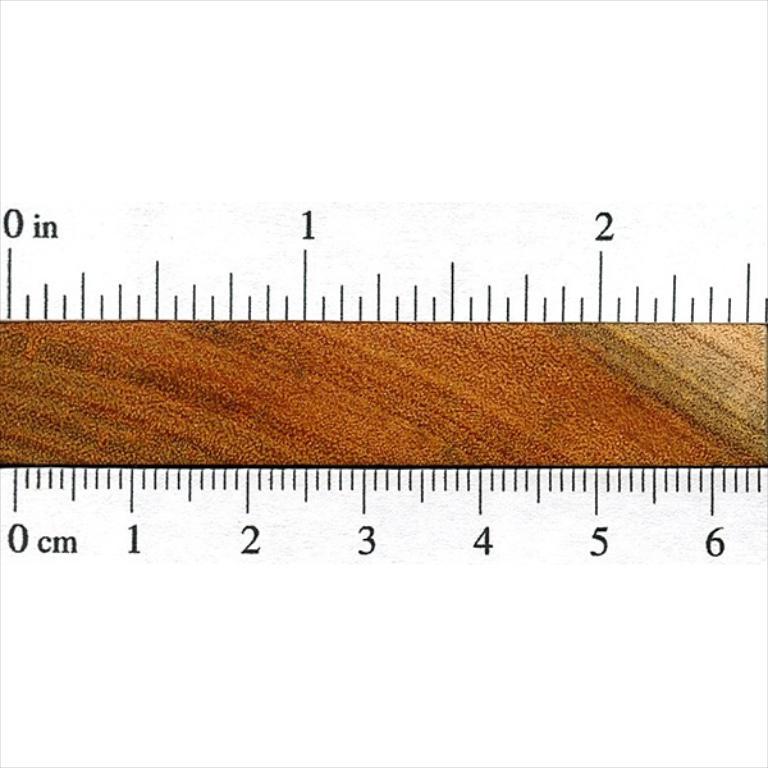How many inches long is this?
Provide a succinct answer. 3. How many centimeters are showing?
Provide a succinct answer. 6. 